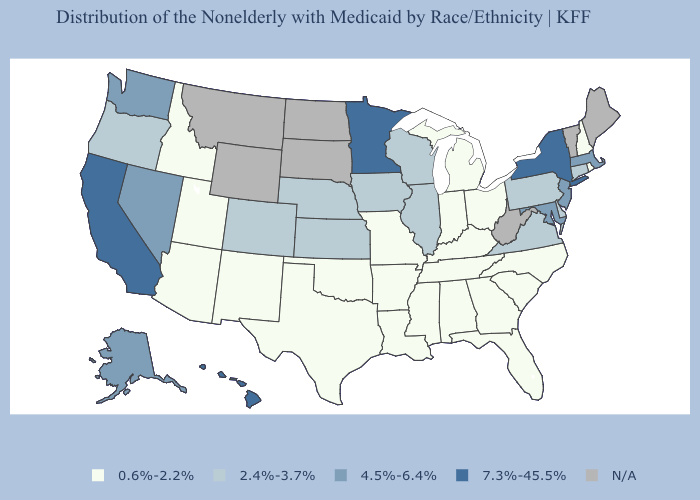Among the states that border Vermont , does Massachusetts have the highest value?
Concise answer only. No. Name the states that have a value in the range 2.4%-3.7%?
Short answer required. Colorado, Connecticut, Delaware, Illinois, Iowa, Kansas, Nebraska, Oregon, Pennsylvania, Virginia, Wisconsin. Name the states that have a value in the range N/A?
Write a very short answer. Maine, Montana, North Dakota, South Dakota, Vermont, West Virginia, Wyoming. Among the states that border Florida , which have the lowest value?
Answer briefly. Alabama, Georgia. How many symbols are there in the legend?
Concise answer only. 5. Name the states that have a value in the range 7.3%-45.5%?
Concise answer only. California, Hawaii, Minnesota, New York. Does the map have missing data?
Answer briefly. Yes. Name the states that have a value in the range 7.3%-45.5%?
Concise answer only. California, Hawaii, Minnesota, New York. Does California have the highest value in the USA?
Write a very short answer. Yes. What is the value of Arizona?
Be succinct. 0.6%-2.2%. Name the states that have a value in the range 4.5%-6.4%?
Quick response, please. Alaska, Maryland, Massachusetts, Nevada, New Jersey, Washington. What is the value of Indiana?
Give a very brief answer. 0.6%-2.2%. Does Hawaii have the lowest value in the West?
Keep it brief. No. 